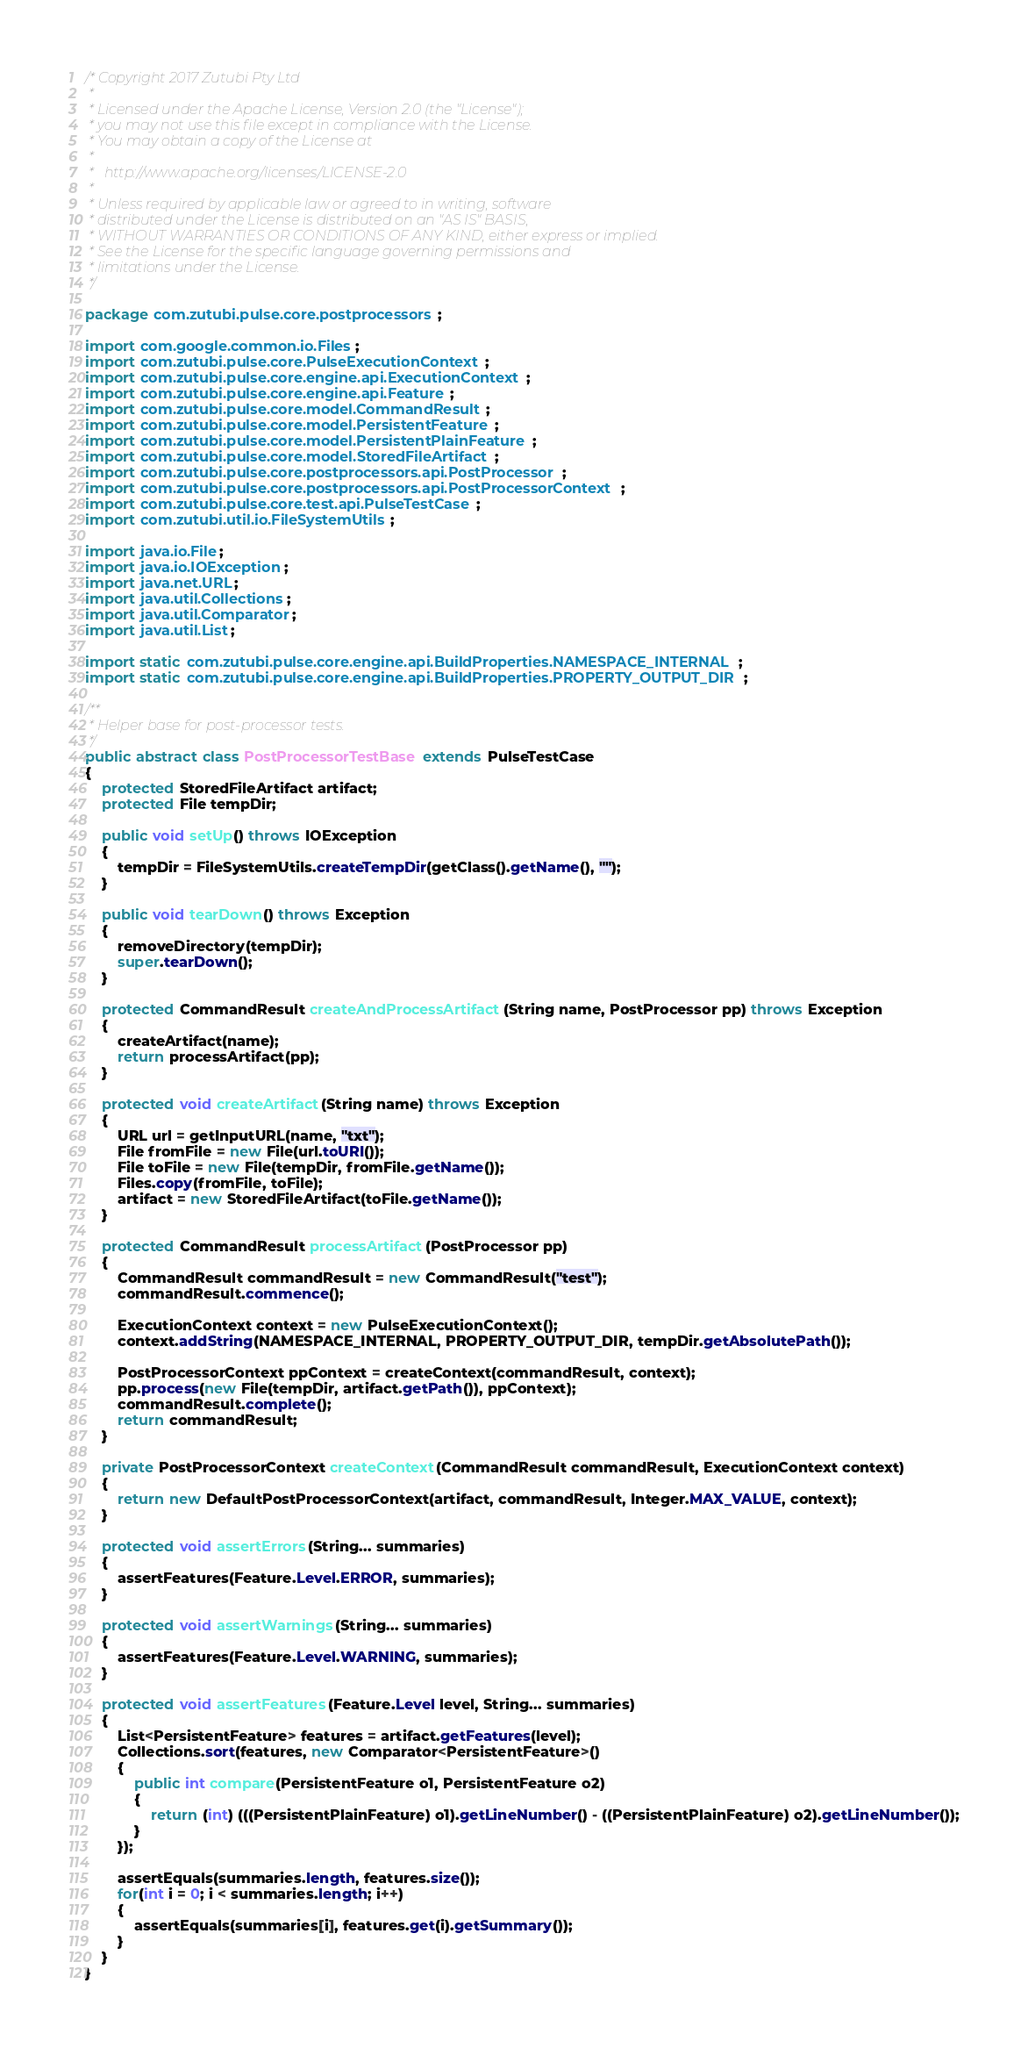Convert code to text. <code><loc_0><loc_0><loc_500><loc_500><_Java_>/* Copyright 2017 Zutubi Pty Ltd
 *
 * Licensed under the Apache License, Version 2.0 (the "License");
 * you may not use this file except in compliance with the License.
 * You may obtain a copy of the License at
 *
 *   http://www.apache.org/licenses/LICENSE-2.0
 *
 * Unless required by applicable law or agreed to in writing, software
 * distributed under the License is distributed on an "AS IS" BASIS,
 * WITHOUT WARRANTIES OR CONDITIONS OF ANY KIND, either express or implied.
 * See the License for the specific language governing permissions and
 * limitations under the License.
 */

package com.zutubi.pulse.core.postprocessors;

import com.google.common.io.Files;
import com.zutubi.pulse.core.PulseExecutionContext;
import com.zutubi.pulse.core.engine.api.ExecutionContext;
import com.zutubi.pulse.core.engine.api.Feature;
import com.zutubi.pulse.core.model.CommandResult;
import com.zutubi.pulse.core.model.PersistentFeature;
import com.zutubi.pulse.core.model.PersistentPlainFeature;
import com.zutubi.pulse.core.model.StoredFileArtifact;
import com.zutubi.pulse.core.postprocessors.api.PostProcessor;
import com.zutubi.pulse.core.postprocessors.api.PostProcessorContext;
import com.zutubi.pulse.core.test.api.PulseTestCase;
import com.zutubi.util.io.FileSystemUtils;

import java.io.File;
import java.io.IOException;
import java.net.URL;
import java.util.Collections;
import java.util.Comparator;
import java.util.List;

import static com.zutubi.pulse.core.engine.api.BuildProperties.NAMESPACE_INTERNAL;
import static com.zutubi.pulse.core.engine.api.BuildProperties.PROPERTY_OUTPUT_DIR;

/**
 * Helper base for post-processor tests.
 */
public abstract class PostProcessorTestBase extends PulseTestCase
{
    protected StoredFileArtifact artifact;
    protected File tempDir;

    public void setUp() throws IOException
    {
        tempDir = FileSystemUtils.createTempDir(getClass().getName(), "");
    }

    public void tearDown() throws Exception
    {
        removeDirectory(tempDir);
        super.tearDown();
    }

    protected CommandResult createAndProcessArtifact(String name, PostProcessor pp) throws Exception
    {
        createArtifact(name);
        return processArtifact(pp);
    }

    protected void createArtifact(String name) throws Exception
    {
        URL url = getInputURL(name, "txt");
        File fromFile = new File(url.toURI());
        File toFile = new File(tempDir, fromFile.getName());
        Files.copy(fromFile, toFile);
        artifact = new StoredFileArtifact(toFile.getName());
    }

    protected CommandResult processArtifact(PostProcessor pp)
    {
        CommandResult commandResult = new CommandResult("test");
        commandResult.commence();

        ExecutionContext context = new PulseExecutionContext();
        context.addString(NAMESPACE_INTERNAL, PROPERTY_OUTPUT_DIR, tempDir.getAbsolutePath());

        PostProcessorContext ppContext = createContext(commandResult, context);
        pp.process(new File(tempDir, artifact.getPath()), ppContext);
        commandResult.complete();
        return commandResult;
    }

    private PostProcessorContext createContext(CommandResult commandResult, ExecutionContext context)
    {
        return new DefaultPostProcessorContext(artifact, commandResult, Integer.MAX_VALUE, context);
    }

    protected void assertErrors(String... summaries)
    {
        assertFeatures(Feature.Level.ERROR, summaries);
    }

    protected void assertWarnings(String... summaries)
    {
        assertFeatures(Feature.Level.WARNING, summaries);
    }

    protected void assertFeatures(Feature.Level level, String... summaries)
    {
        List<PersistentFeature> features = artifact.getFeatures(level);
        Collections.sort(features, new Comparator<PersistentFeature>()
        {
            public int compare(PersistentFeature o1, PersistentFeature o2)
            {
                return (int) (((PersistentPlainFeature) o1).getLineNumber() - ((PersistentPlainFeature) o2).getLineNumber());
            }
        });
        
        assertEquals(summaries.length, features.size());
        for(int i = 0; i < summaries.length; i++)
        {
            assertEquals(summaries[i], features.get(i).getSummary());
        }
    }
}
</code> 